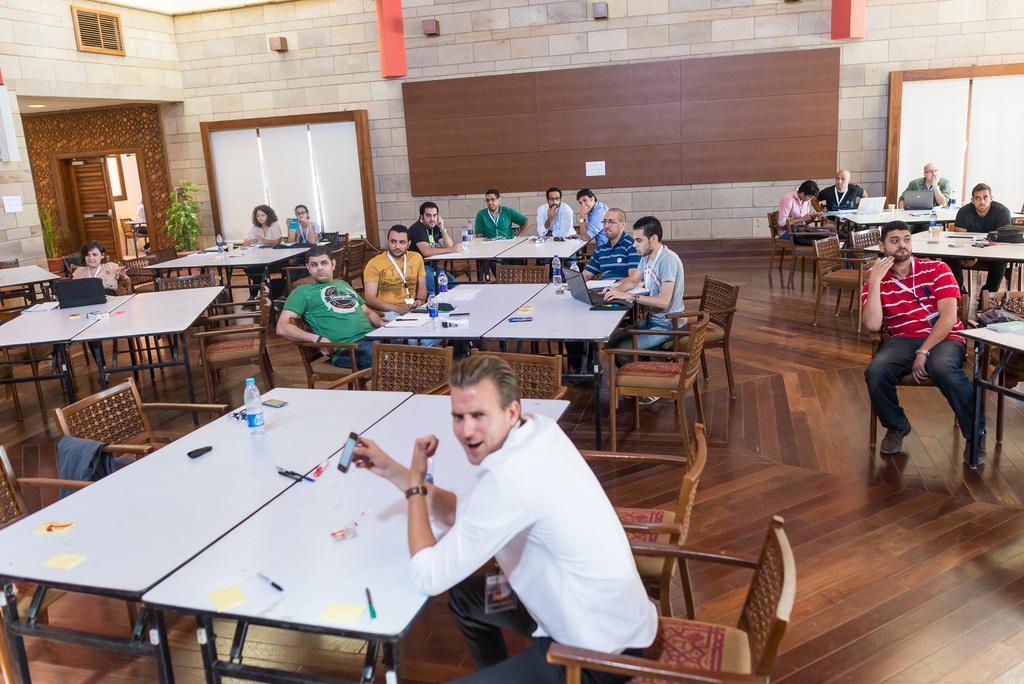How would you summarize this image in a sentence or two? There are few people sitting on the chairs. These are the tables. On these tables I can see water bottles,pens,laptops and few other things placed on it. These are the empty chairs. This is a house plant at the corner. This looks like a window covered with curtains. This is a wooden thing which is attached to the wall. This looks like a door which is opened. I can see a red color object hanging. This is a wooden floor. 